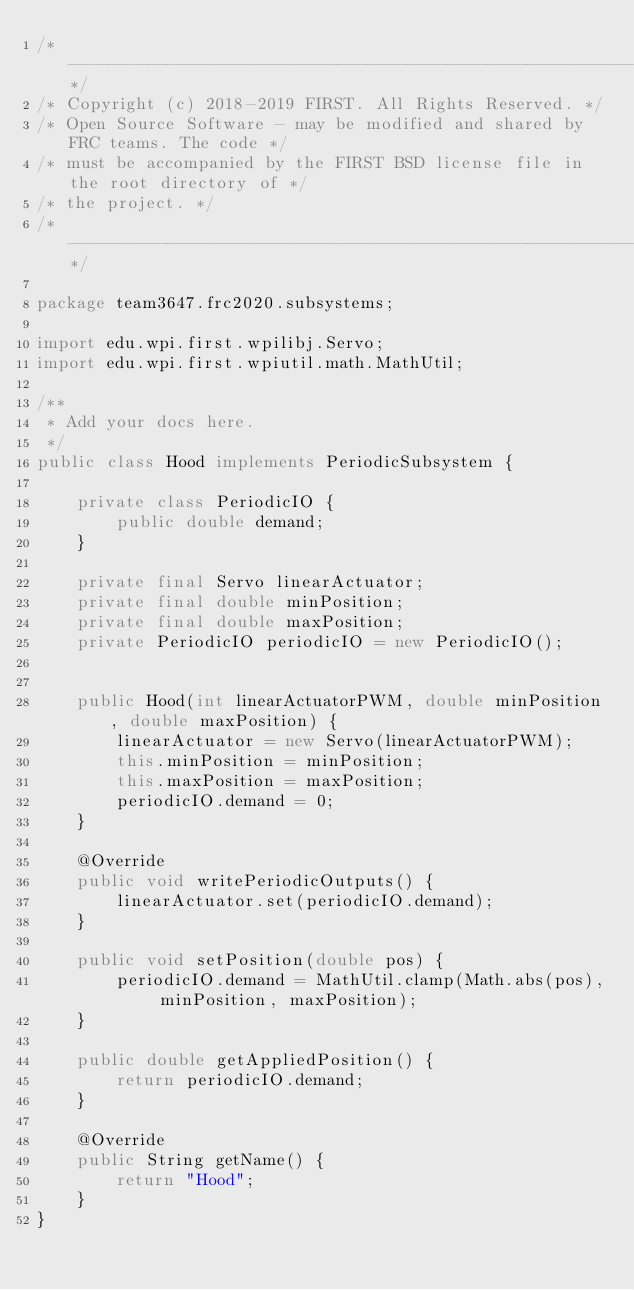<code> <loc_0><loc_0><loc_500><loc_500><_Java_>/*----------------------------------------------------------------------------*/
/* Copyright (c) 2018-2019 FIRST. All Rights Reserved. */
/* Open Source Software - may be modified and shared by FRC teams. The code */
/* must be accompanied by the FIRST BSD license file in the root directory of */
/* the project. */
/*----------------------------------------------------------------------------*/

package team3647.frc2020.subsystems;

import edu.wpi.first.wpilibj.Servo;
import edu.wpi.first.wpiutil.math.MathUtil;

/**
 * Add your docs here.
 */
public class Hood implements PeriodicSubsystem {

    private class PeriodicIO {
        public double demand;
    }

    private final Servo linearActuator;
    private final double minPosition;
    private final double maxPosition;
    private PeriodicIO periodicIO = new PeriodicIO();


    public Hood(int linearActuatorPWM, double minPosition, double maxPosition) {
        linearActuator = new Servo(linearActuatorPWM);
        this.minPosition = minPosition;
        this.maxPosition = maxPosition;
        periodicIO.demand = 0;
    }

    @Override
    public void writePeriodicOutputs() {
        linearActuator.set(periodicIO.demand);
    }

    public void setPosition(double pos) {
        periodicIO.demand = MathUtil.clamp(Math.abs(pos), minPosition, maxPosition);
    }

    public double getAppliedPosition() {
        return periodicIO.demand;
    }

    @Override
    public String getName() {
        return "Hood";
    }
}
</code> 